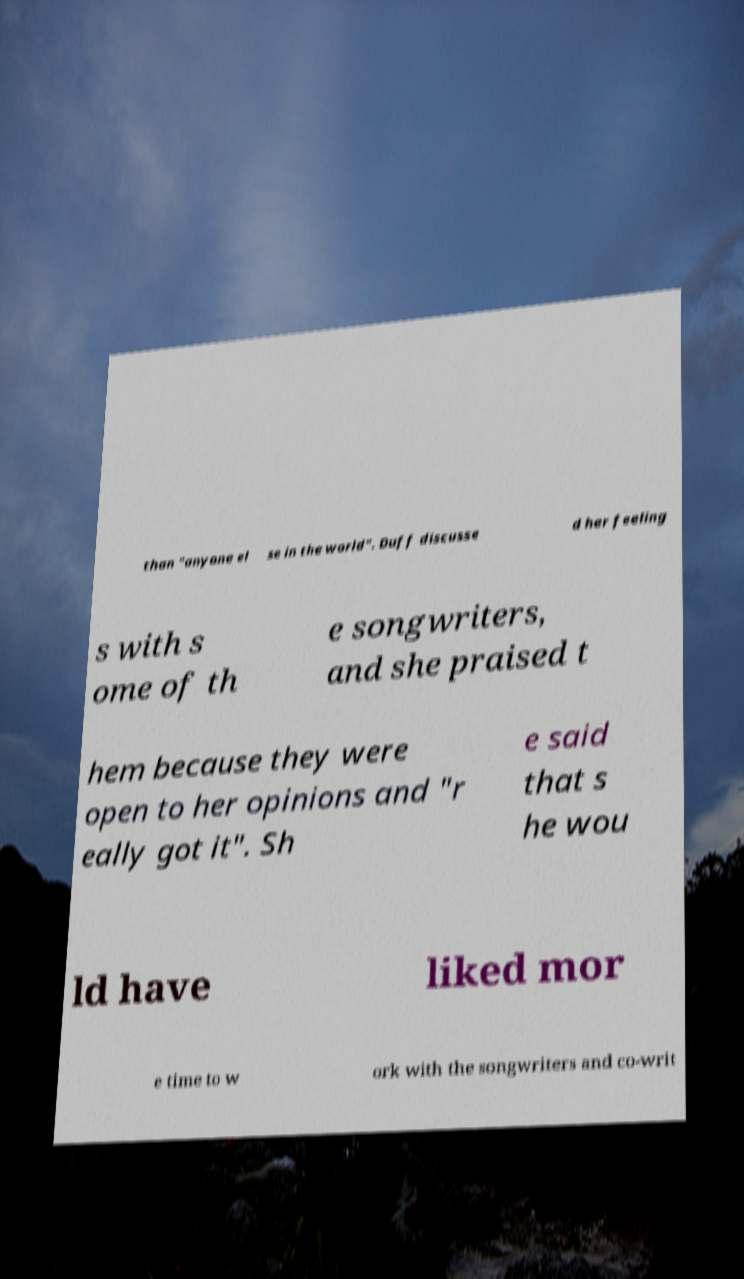What messages or text are displayed in this image? I need them in a readable, typed format. than "anyone el se in the world". Duff discusse d her feeling s with s ome of th e songwriters, and she praised t hem because they were open to her opinions and "r eally got it". Sh e said that s he wou ld have liked mor e time to w ork with the songwriters and co-writ 